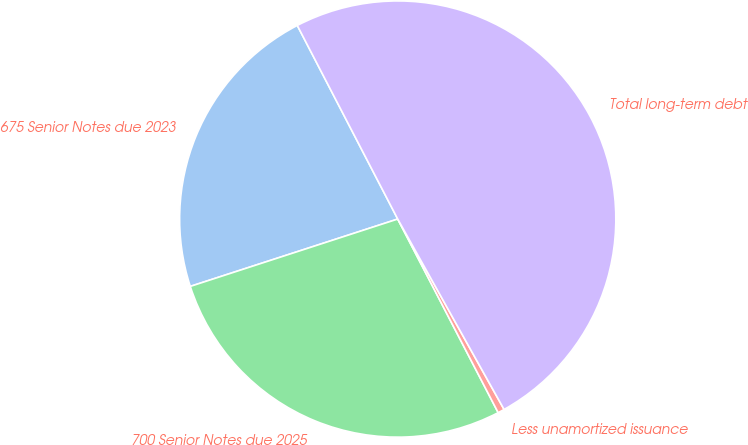Convert chart. <chart><loc_0><loc_0><loc_500><loc_500><pie_chart><fcel>675 Senior Notes due 2023<fcel>700 Senior Notes due 2025<fcel>Less unamortized issuance<fcel>Total long-term debt<nl><fcel>22.38%<fcel>27.62%<fcel>0.49%<fcel>49.51%<nl></chart> 